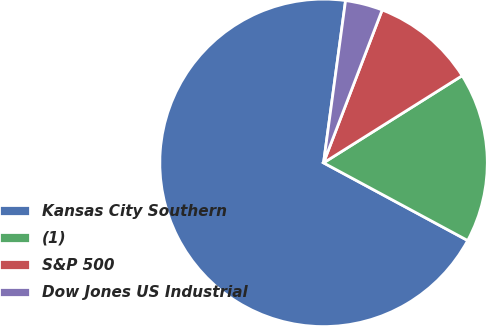<chart> <loc_0><loc_0><loc_500><loc_500><pie_chart><fcel>Kansas City Southern<fcel>(1)<fcel>S&P 500<fcel>Dow Jones US Industrial<nl><fcel>69.28%<fcel>16.8%<fcel>10.24%<fcel>3.68%<nl></chart> 